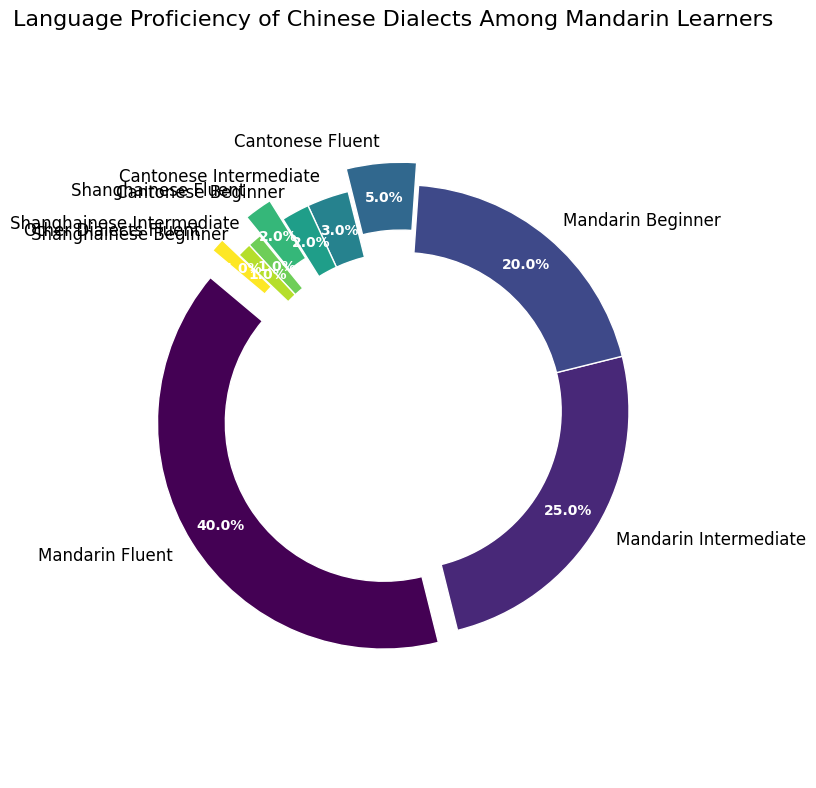Which category has the highest percentage? Observing the ring chart, the largest slice corresponds to "Mandarin Fluent" with an annotated percentage of 40%.
Answer: Mandarin Fluent What is the combined percentage of all Mandarin proficiency levels? Adding up the percentages for "Mandarin Fluent", "Mandarin Intermediate", and "Mandarin Beginner" yields 40% + 25% + 20% = 85%.
Answer: 85% How does the percentage of "Cantonese Fluent" compare to "Shanghainese Fluent"? "Cantonese Fluent" has a percentage of 5%, while "Shanghainese Fluent" has 2%. Thus, "Cantonese Fluent" is higher.
Answer: Cantonese Fluent is greater What is the difference in percentage between "Mandarin Intermediate" and "Cantonese Intermediate"? "Mandarin Intermediate" is 25% and "Cantonese Intermediate" is 3%. The difference is 25% - 3% = 22%.
Answer: 22% What percentage of learners are beginners in any dialect? Summing the percentages for "Mandarin Beginner," "Cantonese Beginner," and "Shanghainese Beginner" yields 20% + 2% + 1% = 23%.
Answer: 23% Which dialect other than Mandarin has a higher proportion of fluent speakers? Comparing "Cantonese Fluent" (5%) to "Shanghainese Fluent" (2%) and "Other Dialects Fluent" (1%), "Cantonese Fluent" is highest.
Answer: Cantonese Is the percentage of "Mandarin Intermediate" learners more or less than twice that of "Mandarin Beginner"? "Mandarin Intermediate" is 25%, and twice "Mandarin Beginner" (20%) is 40%. Since 25% is less than 40%, it is less.
Answer: Less What is the combined percentage of learners who are fluent in any dialect? Adding the percentages for "Mandarin Fluent," "Cantonese Fluent," "Shanghainese Fluent," and "Other Dialects Fluent" gives 40% + 5% + 2% + 1% = 48%.
Answer: 48% Which visualization attributes (like color or positioning) are used to distinguish between proficiency levels? The chart uses different colors for each segment, and fluent categories are slightly exploded to emphasize them.
Answer: Colors and explode effect How many more times fluent Mandarin learners are there compared to fluent learners of any other dialect combined? Fluent Mandarin learners are 40%. Summing the other fluent categories: "Cantonese Fluent," "Shanghainese Fluent," and "Other Dialects Fluent" gives 5% + 2% + 1% = 8%. 40% / 8% = 5 times.
Answer: 5 times 